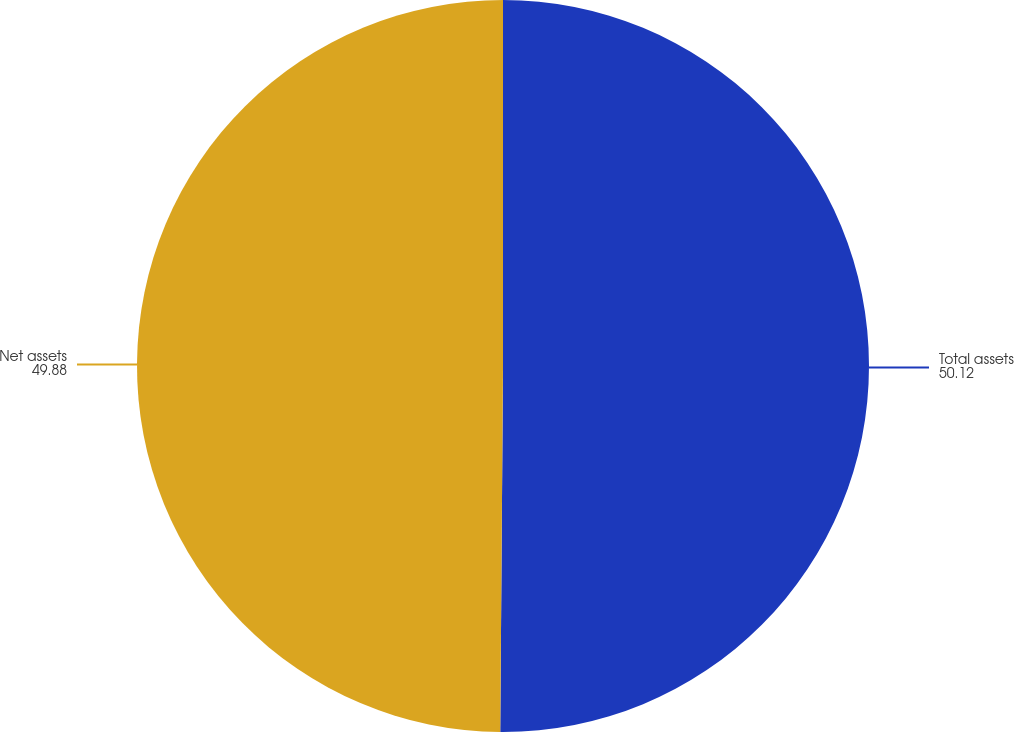<chart> <loc_0><loc_0><loc_500><loc_500><pie_chart><fcel>Total assets<fcel>Net assets<nl><fcel>50.12%<fcel>49.88%<nl></chart> 